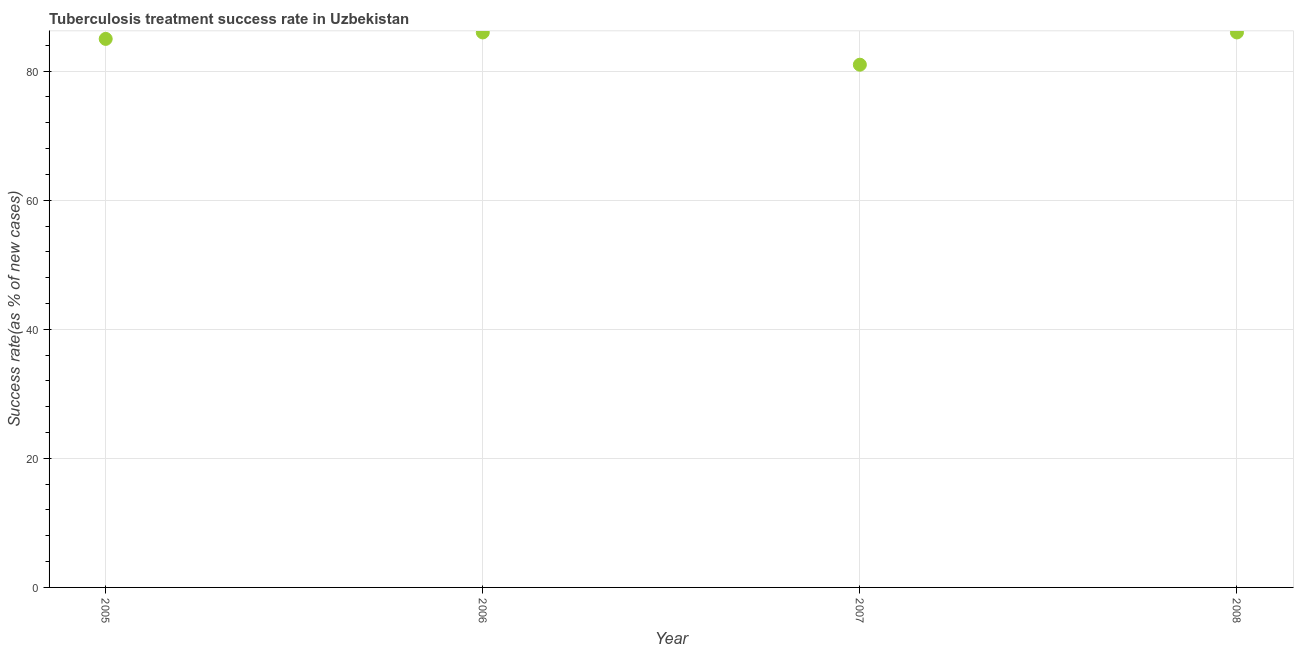What is the tuberculosis treatment success rate in 2006?
Your answer should be very brief. 86. Across all years, what is the maximum tuberculosis treatment success rate?
Your answer should be very brief. 86. Across all years, what is the minimum tuberculosis treatment success rate?
Keep it short and to the point. 81. In which year was the tuberculosis treatment success rate maximum?
Give a very brief answer. 2006. What is the sum of the tuberculosis treatment success rate?
Provide a succinct answer. 338. What is the difference between the tuberculosis treatment success rate in 2005 and 2006?
Offer a terse response. -1. What is the average tuberculosis treatment success rate per year?
Your response must be concise. 84.5. What is the median tuberculosis treatment success rate?
Provide a succinct answer. 85.5. In how many years, is the tuberculosis treatment success rate greater than 8 %?
Give a very brief answer. 4. Do a majority of the years between 2007 and 2006 (inclusive) have tuberculosis treatment success rate greater than 68 %?
Provide a succinct answer. No. What is the ratio of the tuberculosis treatment success rate in 2006 to that in 2007?
Offer a terse response. 1.06. Is the tuberculosis treatment success rate in 2005 less than that in 2007?
Provide a short and direct response. No. Is the difference between the tuberculosis treatment success rate in 2005 and 2006 greater than the difference between any two years?
Your response must be concise. No. What is the difference between the highest and the second highest tuberculosis treatment success rate?
Give a very brief answer. 0. Is the sum of the tuberculosis treatment success rate in 2006 and 2008 greater than the maximum tuberculosis treatment success rate across all years?
Make the answer very short. Yes. What is the difference between the highest and the lowest tuberculosis treatment success rate?
Your response must be concise. 5. How many dotlines are there?
Give a very brief answer. 1. What is the difference between two consecutive major ticks on the Y-axis?
Your answer should be very brief. 20. Are the values on the major ticks of Y-axis written in scientific E-notation?
Keep it short and to the point. No. Does the graph contain grids?
Provide a short and direct response. Yes. What is the title of the graph?
Keep it short and to the point. Tuberculosis treatment success rate in Uzbekistan. What is the label or title of the X-axis?
Offer a terse response. Year. What is the label or title of the Y-axis?
Ensure brevity in your answer.  Success rate(as % of new cases). What is the Success rate(as % of new cases) in 2008?
Provide a short and direct response. 86. What is the difference between the Success rate(as % of new cases) in 2005 and 2006?
Make the answer very short. -1. What is the difference between the Success rate(as % of new cases) in 2005 and 2008?
Offer a very short reply. -1. What is the difference between the Success rate(as % of new cases) in 2006 and 2007?
Keep it short and to the point. 5. What is the difference between the Success rate(as % of new cases) in 2007 and 2008?
Your answer should be very brief. -5. What is the ratio of the Success rate(as % of new cases) in 2005 to that in 2007?
Offer a terse response. 1.05. What is the ratio of the Success rate(as % of new cases) in 2005 to that in 2008?
Offer a very short reply. 0.99. What is the ratio of the Success rate(as % of new cases) in 2006 to that in 2007?
Ensure brevity in your answer.  1.06. What is the ratio of the Success rate(as % of new cases) in 2006 to that in 2008?
Give a very brief answer. 1. What is the ratio of the Success rate(as % of new cases) in 2007 to that in 2008?
Offer a terse response. 0.94. 